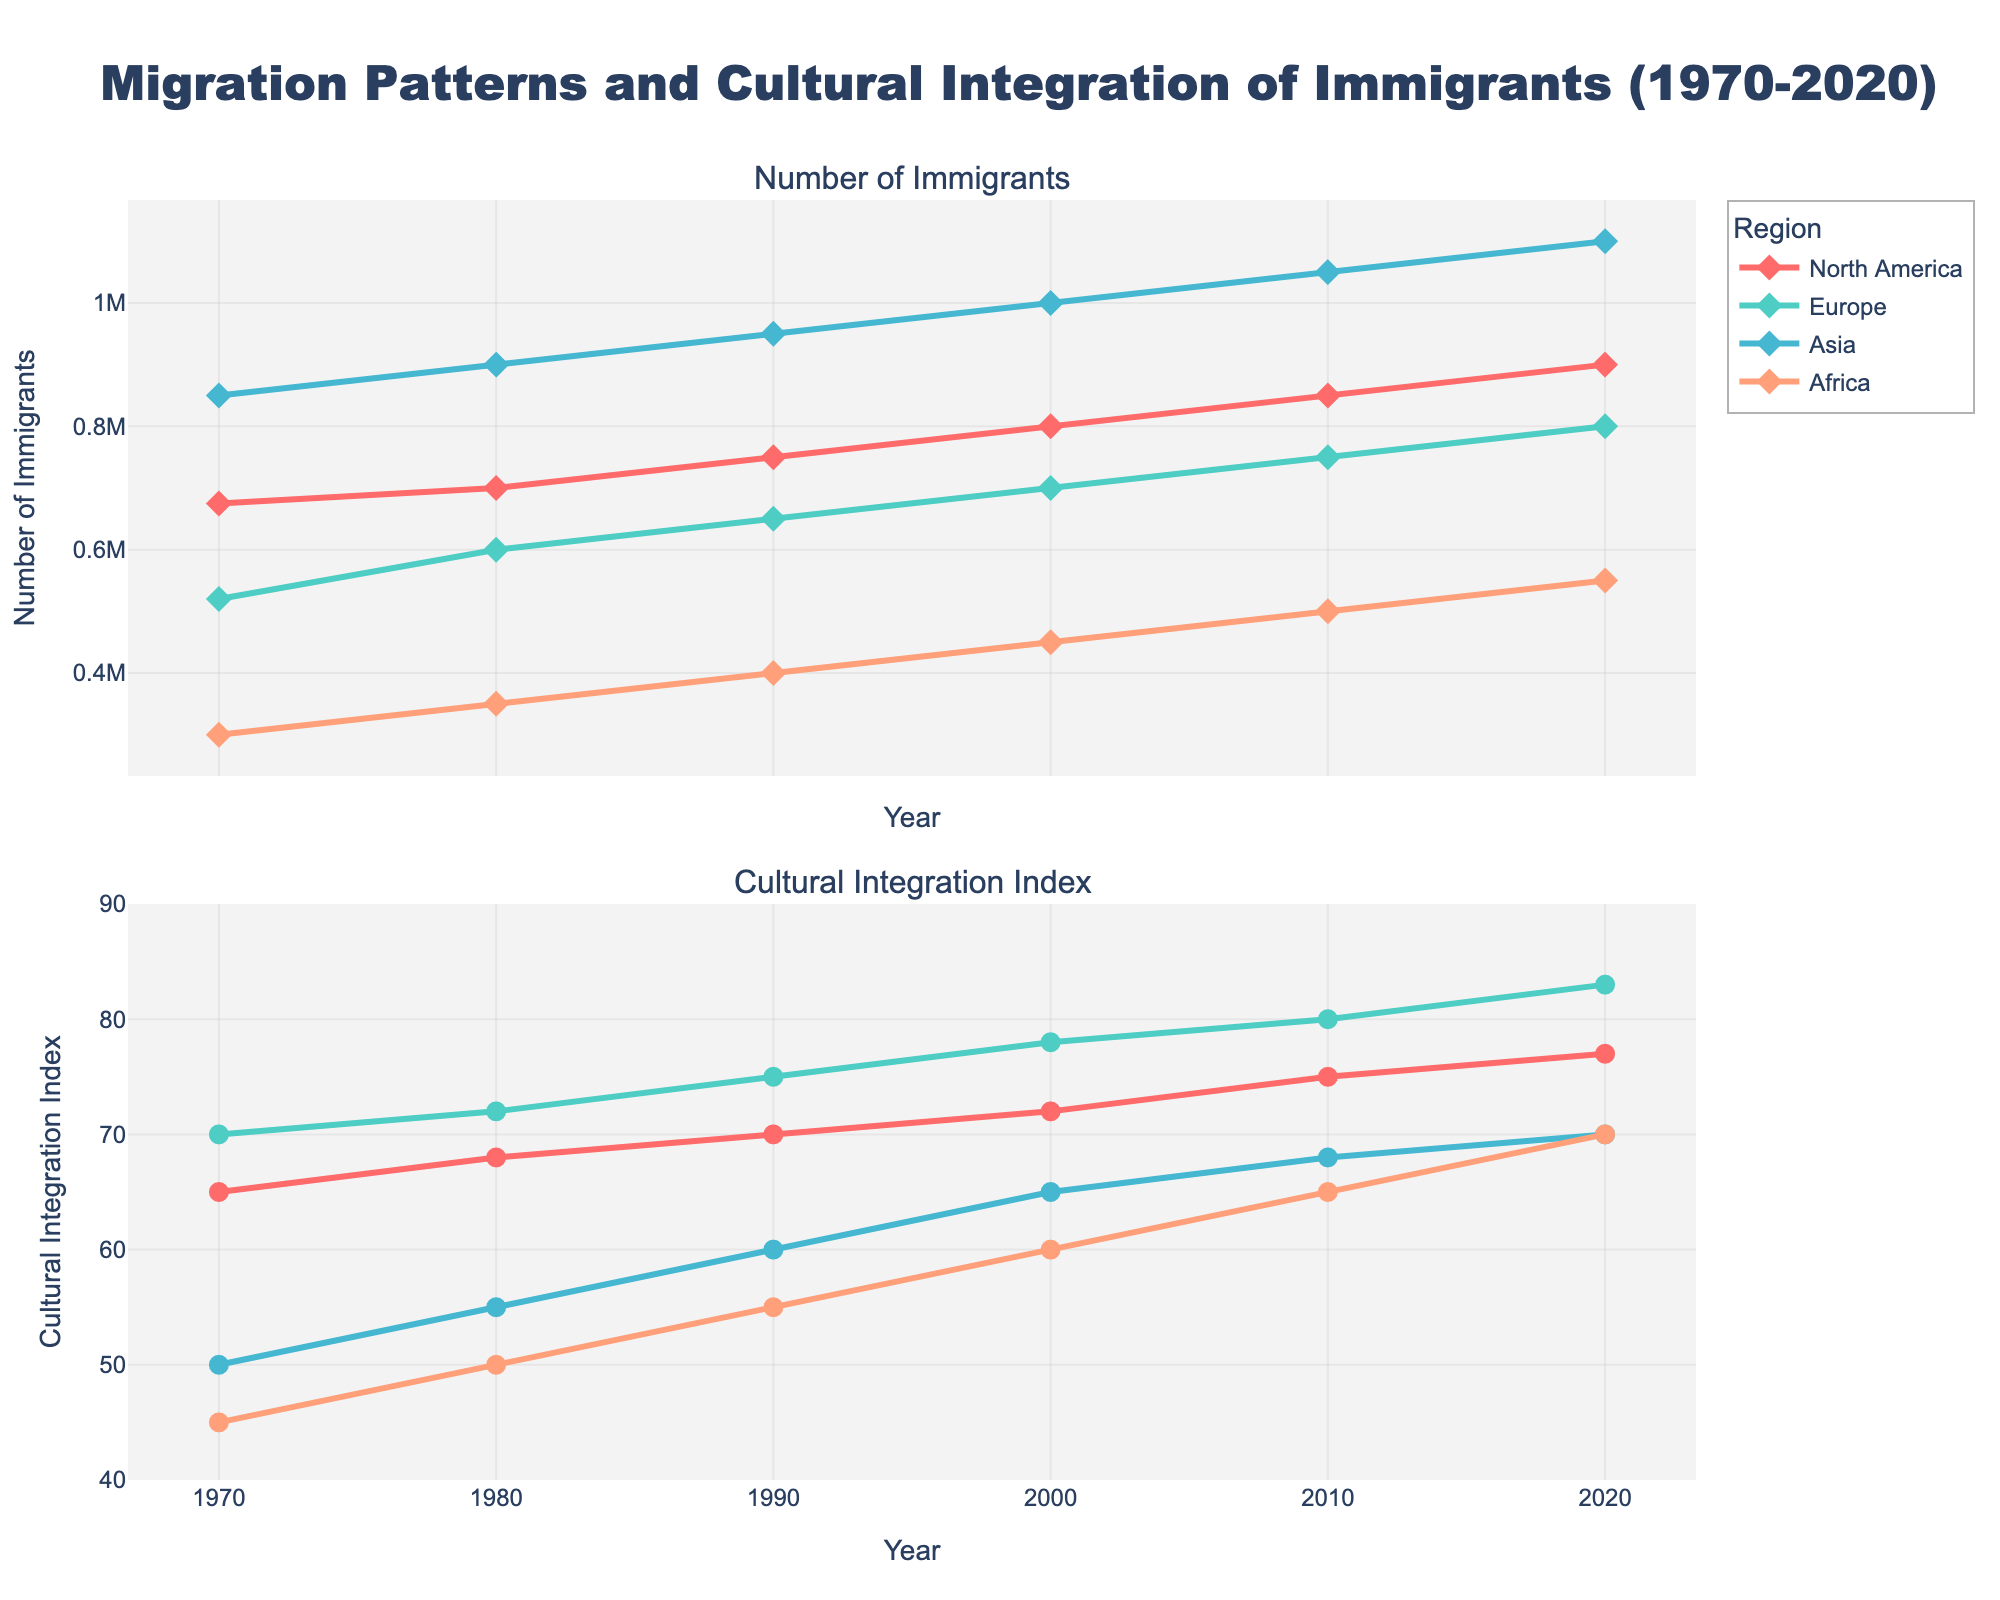What's the title of the plot? The title of the plot is provided at the top of the figure. It summarizes the data being presented.
Answer: Migration Patterns and Cultural Integration of Immigrants (1970-2020) What regions are included in the plot? The regions are labeled as part of the legend in the figure, which identifies each line by its corresponding region.
Answer: North America, Europe, Asia, Africa Which region had the highest number of immigrants in 2020? By observing the top subplot showing the number of immigrants in 2020, the region with the highest number is the one on top.
Answer: Asia How did the number of immigrants from Africa change from 1970 to 2020? Refer to the first subplot and check the line associated with Africa. Compare the data points from 1970 and 2020.
Answer: Increased from 300,000 to 550,000 Compare the Cultural Integration Index of Europe and North America in 2010. Which was higher? Observe the second subplot. Locate the points for Europe and North America in 2010, and compare their Cultural Integration Index values.
Answer: Europe What is the average Cultural Integration Index of Asia between 1970 and 2020? Collect the Cultural Integration Index values for Asia from each decade (50, 55, 60, 65, 68, 70). Sum these values, and divide by the number of data points to find the average. (50 + 55 + 60 + 65 + 68 + 70) / 6 = 61.3
Answer: 61.3 Which region shows the most significant improvement in Cultural Integration Index from 1970 to 2020? Analyze the second subplot for all regions. Determine the difference in Cultural Integration Index from 1970 to 2020 for each region, and identify the region with the largest increase.
Answer: Europe In which decade did North America see the highest increase in the number of immigrants? Look at the first subplot lines for North America and calculate the differences for each decade. Identify the decade with the largest increase.
Answer: 1990 to 2000 What is the total number of immigrants in all regions combined in the year 2000? Sum the number of immigrants from each region in the year 2000 from the first subplot or data. 800,000 + 700,000 + 1,000,000 + 450,000
Answer: 2,950,000 Which region had a Cultural Integration Index below 60 in the most years? Refer to the second subplot and count the number of years each region had an index below 60. Identify the region with the highest count.
Answer: Asia 